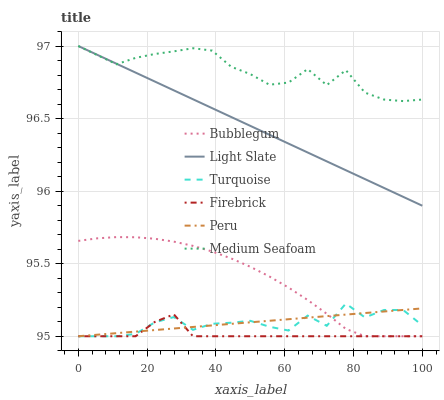Does Firebrick have the minimum area under the curve?
Answer yes or no. Yes. Does Medium Seafoam have the maximum area under the curve?
Answer yes or no. Yes. Does Light Slate have the minimum area under the curve?
Answer yes or no. No. Does Light Slate have the maximum area under the curve?
Answer yes or no. No. Is Peru the smoothest?
Answer yes or no. Yes. Is Turquoise the roughest?
Answer yes or no. Yes. Is Light Slate the smoothest?
Answer yes or no. No. Is Light Slate the roughest?
Answer yes or no. No. Does Turquoise have the lowest value?
Answer yes or no. Yes. Does Light Slate have the lowest value?
Answer yes or no. No. Does Medium Seafoam have the highest value?
Answer yes or no. Yes. Does Firebrick have the highest value?
Answer yes or no. No. Is Firebrick less than Light Slate?
Answer yes or no. Yes. Is Light Slate greater than Firebrick?
Answer yes or no. Yes. Does Bubblegum intersect Peru?
Answer yes or no. Yes. Is Bubblegum less than Peru?
Answer yes or no. No. Is Bubblegum greater than Peru?
Answer yes or no. No. Does Firebrick intersect Light Slate?
Answer yes or no. No. 